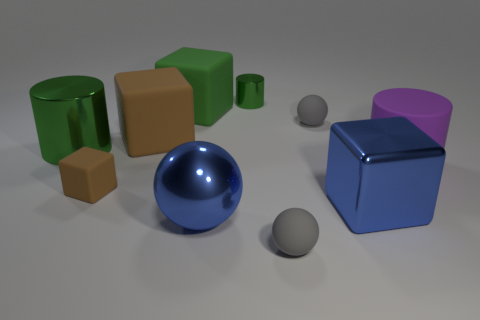Subtract all balls. How many objects are left? 7 Add 7 purple rubber cylinders. How many purple rubber cylinders exist? 8 Subtract 0 brown spheres. How many objects are left? 10 Subtract all tiny gray balls. Subtract all big purple cylinders. How many objects are left? 7 Add 8 brown things. How many brown things are left? 10 